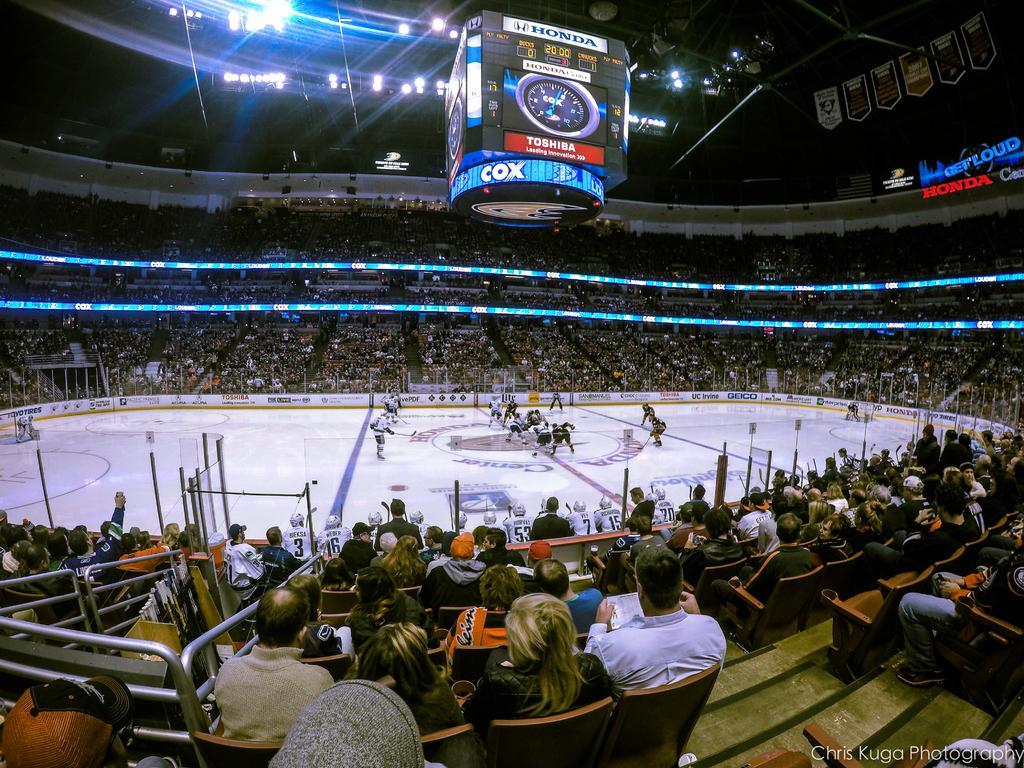Describe this image in one or two sentences. In the image we can see there are many people sitting and wearing clothes. There are many chairs and posters, here we can see the lights and LED text. Here we can see snow surface and there are people wearing clothes and snow skiing shoes. On the bottom right we can see the watermark. 